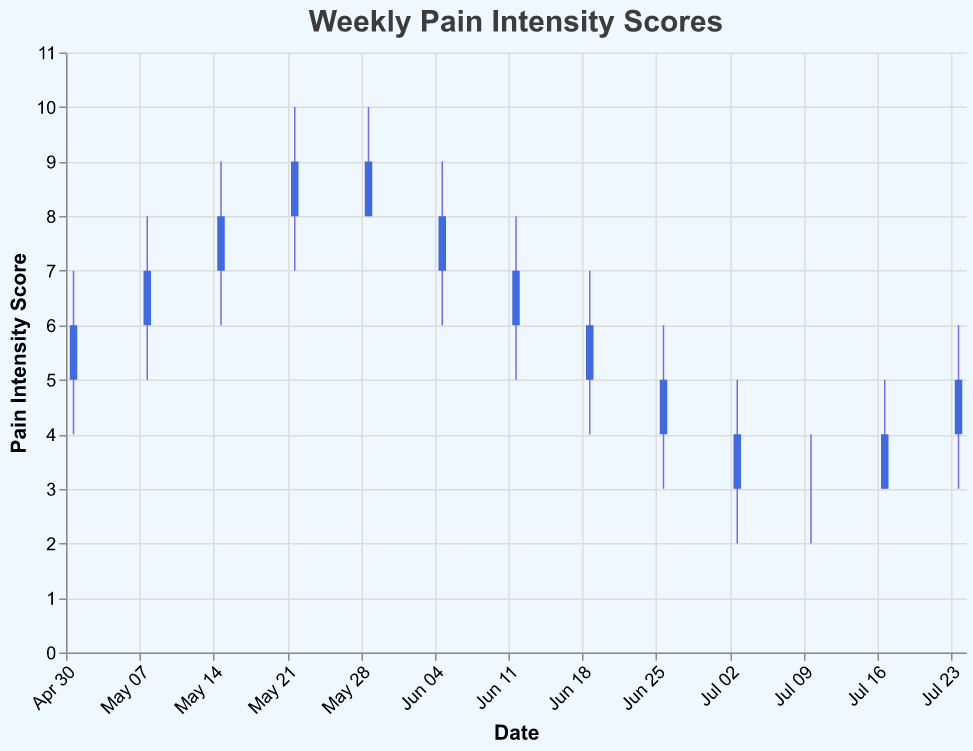What is the title of the chart? The title is presented at the top of the chart and reads "Weekly Pain Intensity Scores".
Answer: Weekly Pain Intensity Scores How many weeks of data are represented in the OHLC chart? Count the number of data points in the dataset. There are 13 entries corresponding to 13 weeks of data.
Answer: 13 What is the highest pain intensity recorded in the chart? Look for the highest value in the 'High' column. The maximum value is 10.
Answer: 10 Between which dates did the pain intensity show a consistent decrease? Pain intensity consistently decreased from 2023-05-29 to 2023-07-03, as observed from the Close values moving from 8 to 3.
Answer: 2023-05-29 to 2023-07-03 During which week did the pain intensity score have the largest range between high and low values? The range between high and low is largest for the week 2023-05-22, where it spans from 10 (High) to 7 (Low), a range of 3.
Answer: 2023-05-22 What was the pain intensity range for the week of 2023-07-17? The high was 5, and the low was 3, so the range is 5 - 3 = 2.
Answer: 2 How did the pain intensity close values change from 2023-05-01 to 2023-06-05? The Close values moved from 6 to 7 during this period, showing an increase of 1.
Answer: Increased by 1 Which week witnessed the lowest pain intensity score? The lowest 'Low' value is 2, which occurred during the weeks of 2023-07-03 and 2023-07-10.
Answer: 2023-07-03 and 2023-07-10 How many weeks show a decrease in the close pain intensity score compared to the previous week? Identify weeks where the Close value decreased compared to the previous week. This occurred in weeks: 2023-05-29, 2023-06-12, 2023-06-19, 2023-06-26.
Answer: 4 Compare the pain intensity Open values for the first and the last week noted in the chart. The Open value on 2023-05-01 is 5, and on 2023-07-24 is 4.
Answer: The last week is 1 unit lower than the first week 